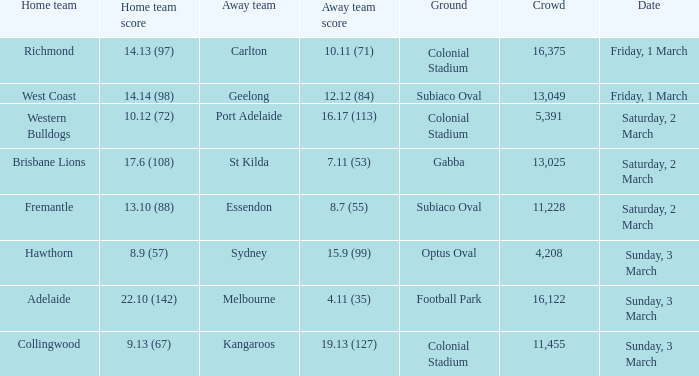What was the basis for the away team sydney? Optus Oval. 